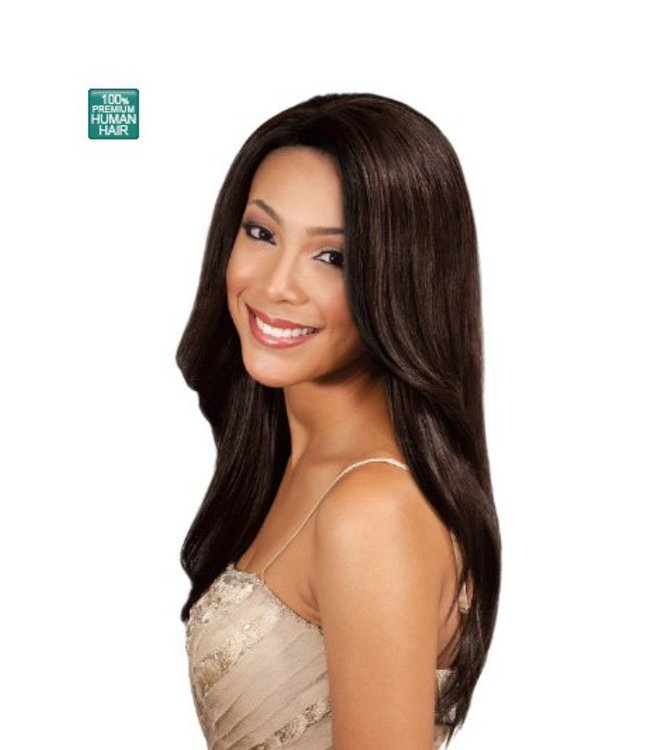The woman in the image looks confident. How might wearing a wig like this affect someone's confidence? Wearing a high-quality wig made from 100% human hair, like the one shown in the image, can significantly boost a person's confidence. The realistic appearance and feel of the wig can enhance one's self-esteem by providing a natural look. This can be especially empowering for individuals experiencing hair loss or those who want to change their hairstyle without making permanent changes to their natural hair. The confidence gained from looking good often translates into better social interactions and a positive self-image. 